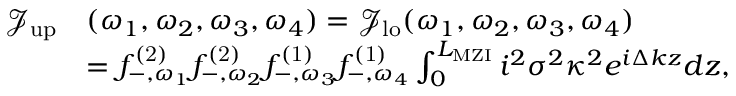<formula> <loc_0><loc_0><loc_500><loc_500>\begin{array} { r l } { \mathcal { J } _ { u p } } & { ( \omega _ { 1 } , \omega _ { 2 } , \omega _ { 3 } , \omega _ { 4 } ) = \mathcal { J } _ { l o } ( \omega _ { 1 } , \omega _ { 2 } , \omega _ { 3 } , \omega _ { 4 } ) } \\ & { = { f } _ { - , \omega _ { 1 } } ^ { ( 2 ) } { f } _ { - , \omega _ { 2 } } ^ { ( 2 ) } { f } _ { - , \omega _ { 3 } } ^ { ( 1 ) } { f } _ { - , \omega _ { 4 } } ^ { ( 1 ) } \int _ { 0 } ^ { L _ { M Z I } } i ^ { 2 } \sigma ^ { 2 } \kappa ^ { 2 } e ^ { i \Delta k z } d z , } \end{array}</formula> 